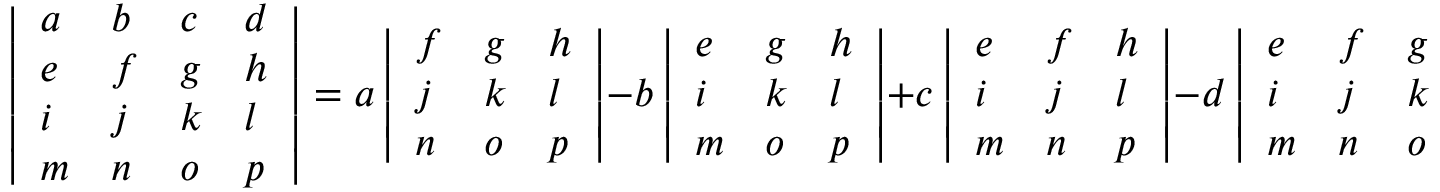Convert formula to latex. <formula><loc_0><loc_0><loc_500><loc_500>{ \left | \begin{array} { l l l l } { a } & { b } & { c } & { d } \\ { e } & { f } & { g } & { h } \\ { i } & { j } & { k } & { l } \\ { m } & { n } & { o } & { p } \end{array} \right | } = a \, { \left | \begin{array} { l l l } { f } & { g } & { h } \\ { j } & { k } & { l } \\ { n } & { o } & { p } \end{array} \right | } - b \, { \left | \begin{array} { l l l } { e } & { g } & { h } \\ { i } & { k } & { l } \\ { m } & { o } & { p } \end{array} \right | } + c \, { \left | \begin{array} { l l l } { e } & { f } & { h } \\ { i } & { j } & { l } \\ { m } & { n } & { p } \end{array} \right | } - d \, { \left | \begin{array} { l l l } { e } & { f } & { g } \\ { i } & { j } & { k } \\ { m } & { n } & { o } \end{array} \right | } .</formula> 